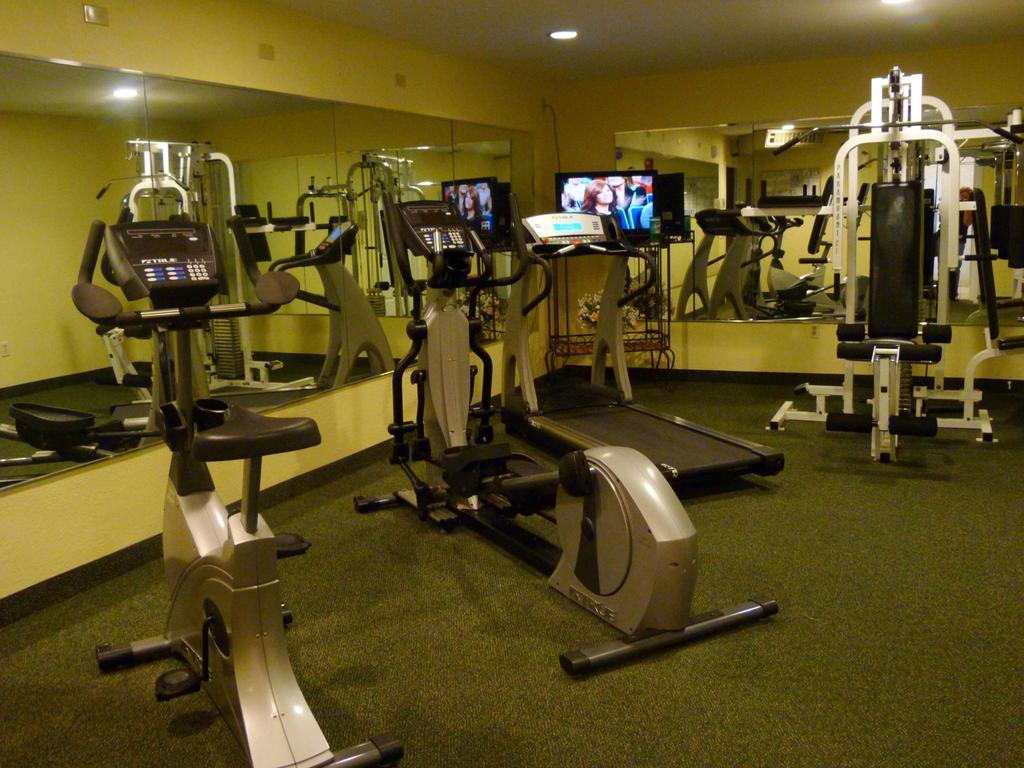Please provide a concise description of this image. In this image we can see exercise machines. In the back there is a TV on a stand. There are lights. Also there are walls with mirror. 